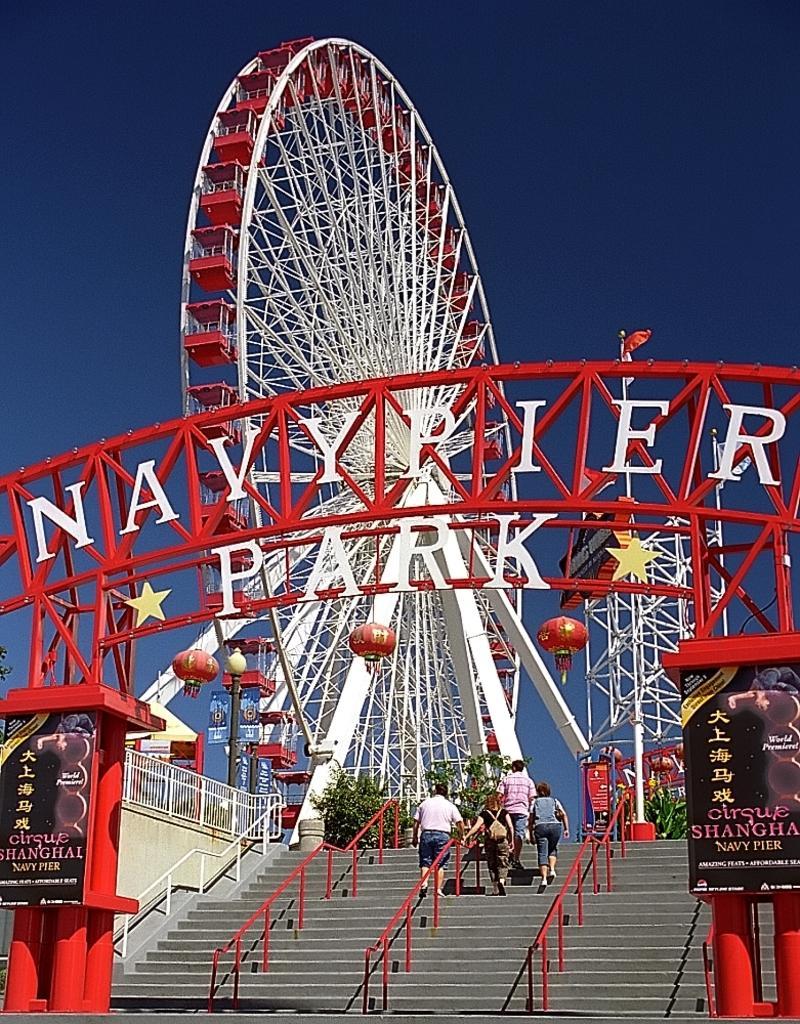How would you summarize this image in a sentence or two? In this image we can see the arch and on the arch we can see the text and also the posters. Behind the arch we can see the giant wheel. We can also see few people on the stairs. In the background we can see the sky. 